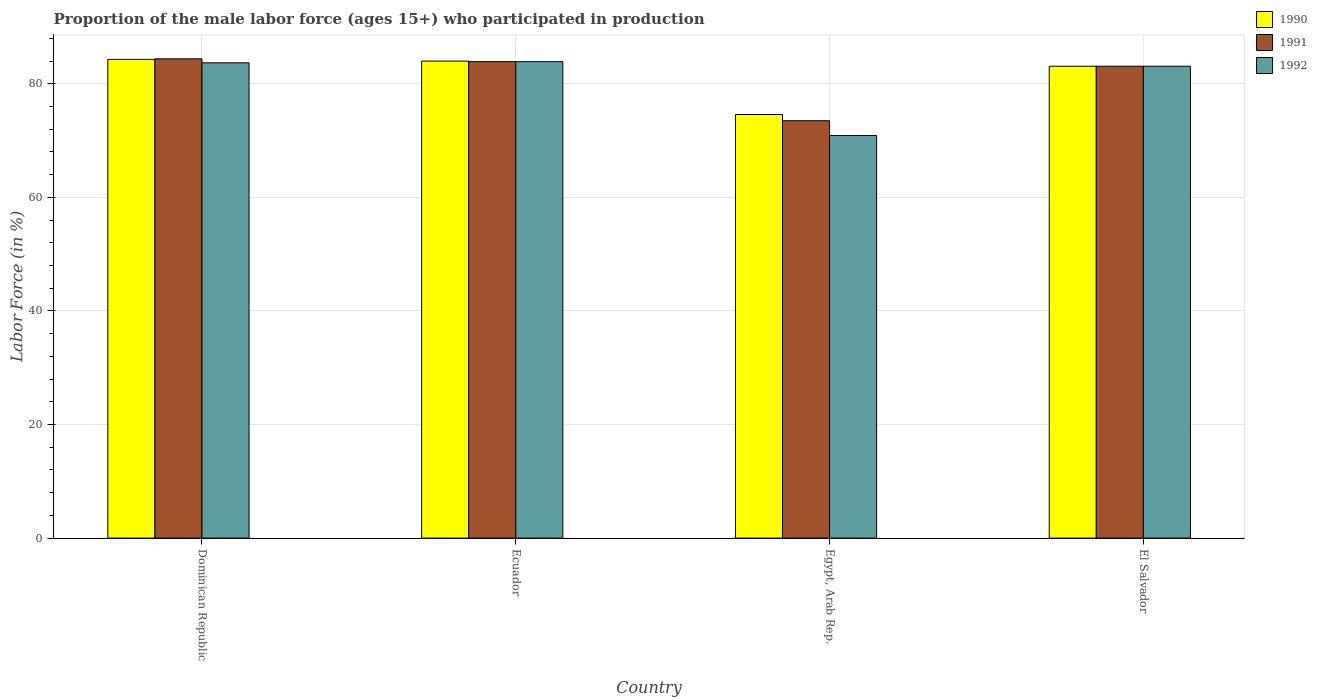Are the number of bars per tick equal to the number of legend labels?
Provide a succinct answer. Yes. How many bars are there on the 3rd tick from the right?
Ensure brevity in your answer.  3. What is the label of the 2nd group of bars from the left?
Offer a very short reply. Ecuador. In how many cases, is the number of bars for a given country not equal to the number of legend labels?
Provide a short and direct response. 0. What is the proportion of the male labor force who participated in production in 1991 in Ecuador?
Your answer should be very brief. 83.9. Across all countries, what is the maximum proportion of the male labor force who participated in production in 1991?
Offer a terse response. 84.4. Across all countries, what is the minimum proportion of the male labor force who participated in production in 1992?
Keep it short and to the point. 70.9. In which country was the proportion of the male labor force who participated in production in 1990 maximum?
Give a very brief answer. Dominican Republic. In which country was the proportion of the male labor force who participated in production in 1991 minimum?
Provide a succinct answer. Egypt, Arab Rep. What is the total proportion of the male labor force who participated in production in 1991 in the graph?
Give a very brief answer. 324.9. What is the difference between the proportion of the male labor force who participated in production in 1991 in Ecuador and that in El Salvador?
Your response must be concise. 0.8. What is the difference between the proportion of the male labor force who participated in production in 1990 in El Salvador and the proportion of the male labor force who participated in production in 1992 in Dominican Republic?
Ensure brevity in your answer.  -0.6. What is the average proportion of the male labor force who participated in production in 1992 per country?
Ensure brevity in your answer.  80.4. What is the difference between the proportion of the male labor force who participated in production of/in 1990 and proportion of the male labor force who participated in production of/in 1991 in Egypt, Arab Rep.?
Provide a succinct answer. 1.1. What is the ratio of the proportion of the male labor force who participated in production in 1992 in Dominican Republic to that in Ecuador?
Your answer should be compact. 1. Is the proportion of the male labor force who participated in production in 1990 in Dominican Republic less than that in Egypt, Arab Rep.?
Make the answer very short. No. Is the difference between the proportion of the male labor force who participated in production in 1990 in Dominican Republic and El Salvador greater than the difference between the proportion of the male labor force who participated in production in 1991 in Dominican Republic and El Salvador?
Your answer should be compact. No. What is the difference between the highest and the second highest proportion of the male labor force who participated in production in 1992?
Your answer should be very brief. -0.6. What is the difference between the highest and the lowest proportion of the male labor force who participated in production in 1991?
Your answer should be compact. 10.9. In how many countries, is the proportion of the male labor force who participated in production in 1992 greater than the average proportion of the male labor force who participated in production in 1992 taken over all countries?
Your response must be concise. 3. What does the 2nd bar from the right in El Salvador represents?
Your answer should be very brief. 1991. Is it the case that in every country, the sum of the proportion of the male labor force who participated in production in 1991 and proportion of the male labor force who participated in production in 1990 is greater than the proportion of the male labor force who participated in production in 1992?
Provide a succinct answer. Yes. Are the values on the major ticks of Y-axis written in scientific E-notation?
Keep it short and to the point. No. What is the title of the graph?
Your response must be concise. Proportion of the male labor force (ages 15+) who participated in production. Does "1981" appear as one of the legend labels in the graph?
Your answer should be very brief. No. What is the label or title of the Y-axis?
Provide a short and direct response. Labor Force (in %). What is the Labor Force (in %) in 1990 in Dominican Republic?
Make the answer very short. 84.3. What is the Labor Force (in %) of 1991 in Dominican Republic?
Keep it short and to the point. 84.4. What is the Labor Force (in %) in 1992 in Dominican Republic?
Make the answer very short. 83.7. What is the Labor Force (in %) in 1990 in Ecuador?
Offer a very short reply. 84. What is the Labor Force (in %) of 1991 in Ecuador?
Give a very brief answer. 83.9. What is the Labor Force (in %) in 1992 in Ecuador?
Provide a succinct answer. 83.9. What is the Labor Force (in %) of 1990 in Egypt, Arab Rep.?
Keep it short and to the point. 74.6. What is the Labor Force (in %) in 1991 in Egypt, Arab Rep.?
Your answer should be very brief. 73.5. What is the Labor Force (in %) in 1992 in Egypt, Arab Rep.?
Your answer should be compact. 70.9. What is the Labor Force (in %) in 1990 in El Salvador?
Make the answer very short. 83.1. What is the Labor Force (in %) of 1991 in El Salvador?
Your answer should be very brief. 83.1. What is the Labor Force (in %) of 1992 in El Salvador?
Offer a very short reply. 83.1. Across all countries, what is the maximum Labor Force (in %) of 1990?
Make the answer very short. 84.3. Across all countries, what is the maximum Labor Force (in %) in 1991?
Offer a very short reply. 84.4. Across all countries, what is the maximum Labor Force (in %) in 1992?
Keep it short and to the point. 83.9. Across all countries, what is the minimum Labor Force (in %) in 1990?
Make the answer very short. 74.6. Across all countries, what is the minimum Labor Force (in %) in 1991?
Your answer should be compact. 73.5. Across all countries, what is the minimum Labor Force (in %) in 1992?
Keep it short and to the point. 70.9. What is the total Labor Force (in %) in 1990 in the graph?
Your answer should be very brief. 326. What is the total Labor Force (in %) in 1991 in the graph?
Your response must be concise. 324.9. What is the total Labor Force (in %) of 1992 in the graph?
Provide a succinct answer. 321.6. What is the difference between the Labor Force (in %) in 1992 in Dominican Republic and that in Ecuador?
Offer a very short reply. -0.2. What is the difference between the Labor Force (in %) of 1990 in Dominican Republic and that in Egypt, Arab Rep.?
Ensure brevity in your answer.  9.7. What is the difference between the Labor Force (in %) of 1991 in Dominican Republic and that in Egypt, Arab Rep.?
Provide a succinct answer. 10.9. What is the difference between the Labor Force (in %) in 1992 in Dominican Republic and that in Egypt, Arab Rep.?
Ensure brevity in your answer.  12.8. What is the difference between the Labor Force (in %) in 1990 in Dominican Republic and that in El Salvador?
Your response must be concise. 1.2. What is the difference between the Labor Force (in %) in 1991 in Ecuador and that in Egypt, Arab Rep.?
Offer a very short reply. 10.4. What is the difference between the Labor Force (in %) of 1992 in Ecuador and that in Egypt, Arab Rep.?
Offer a terse response. 13. What is the difference between the Labor Force (in %) in 1990 in Ecuador and that in El Salvador?
Make the answer very short. 0.9. What is the difference between the Labor Force (in %) of 1991 in Ecuador and that in El Salvador?
Keep it short and to the point. 0.8. What is the difference between the Labor Force (in %) of 1992 in Ecuador and that in El Salvador?
Provide a short and direct response. 0.8. What is the difference between the Labor Force (in %) in 1992 in Egypt, Arab Rep. and that in El Salvador?
Provide a short and direct response. -12.2. What is the difference between the Labor Force (in %) of 1990 in Dominican Republic and the Labor Force (in %) of 1991 in Ecuador?
Ensure brevity in your answer.  0.4. What is the difference between the Labor Force (in %) of 1990 in Dominican Republic and the Labor Force (in %) of 1992 in Ecuador?
Offer a terse response. 0.4. What is the difference between the Labor Force (in %) of 1991 in Dominican Republic and the Labor Force (in %) of 1992 in Ecuador?
Keep it short and to the point. 0.5. What is the difference between the Labor Force (in %) in 1991 in Dominican Republic and the Labor Force (in %) in 1992 in Egypt, Arab Rep.?
Provide a short and direct response. 13.5. What is the difference between the Labor Force (in %) in 1990 in Ecuador and the Labor Force (in %) in 1991 in Egypt, Arab Rep.?
Offer a very short reply. 10.5. What is the difference between the Labor Force (in %) of 1990 in Ecuador and the Labor Force (in %) of 1991 in El Salvador?
Ensure brevity in your answer.  0.9. What is the difference between the Labor Force (in %) in 1991 in Ecuador and the Labor Force (in %) in 1992 in El Salvador?
Offer a very short reply. 0.8. What is the difference between the Labor Force (in %) in 1990 in Egypt, Arab Rep. and the Labor Force (in %) in 1991 in El Salvador?
Offer a very short reply. -8.5. What is the average Labor Force (in %) in 1990 per country?
Provide a succinct answer. 81.5. What is the average Labor Force (in %) of 1991 per country?
Give a very brief answer. 81.22. What is the average Labor Force (in %) in 1992 per country?
Make the answer very short. 80.4. What is the difference between the Labor Force (in %) in 1990 and Labor Force (in %) in 1992 in Ecuador?
Keep it short and to the point. 0.1. What is the difference between the Labor Force (in %) of 1990 and Labor Force (in %) of 1991 in El Salvador?
Offer a terse response. 0. What is the difference between the Labor Force (in %) in 1991 and Labor Force (in %) in 1992 in El Salvador?
Offer a very short reply. 0. What is the ratio of the Labor Force (in %) of 1991 in Dominican Republic to that in Ecuador?
Keep it short and to the point. 1.01. What is the ratio of the Labor Force (in %) in 1992 in Dominican Republic to that in Ecuador?
Ensure brevity in your answer.  1. What is the ratio of the Labor Force (in %) of 1990 in Dominican Republic to that in Egypt, Arab Rep.?
Your answer should be compact. 1.13. What is the ratio of the Labor Force (in %) in 1991 in Dominican Republic to that in Egypt, Arab Rep.?
Your response must be concise. 1.15. What is the ratio of the Labor Force (in %) in 1992 in Dominican Republic to that in Egypt, Arab Rep.?
Offer a very short reply. 1.18. What is the ratio of the Labor Force (in %) of 1990 in Dominican Republic to that in El Salvador?
Your answer should be very brief. 1.01. What is the ratio of the Labor Force (in %) of 1991 in Dominican Republic to that in El Salvador?
Provide a short and direct response. 1.02. What is the ratio of the Labor Force (in %) of 1992 in Dominican Republic to that in El Salvador?
Provide a succinct answer. 1.01. What is the ratio of the Labor Force (in %) of 1990 in Ecuador to that in Egypt, Arab Rep.?
Keep it short and to the point. 1.13. What is the ratio of the Labor Force (in %) in 1991 in Ecuador to that in Egypt, Arab Rep.?
Provide a short and direct response. 1.14. What is the ratio of the Labor Force (in %) in 1992 in Ecuador to that in Egypt, Arab Rep.?
Your response must be concise. 1.18. What is the ratio of the Labor Force (in %) of 1990 in Ecuador to that in El Salvador?
Your response must be concise. 1.01. What is the ratio of the Labor Force (in %) in 1991 in Ecuador to that in El Salvador?
Keep it short and to the point. 1.01. What is the ratio of the Labor Force (in %) in 1992 in Ecuador to that in El Salvador?
Ensure brevity in your answer.  1.01. What is the ratio of the Labor Force (in %) in 1990 in Egypt, Arab Rep. to that in El Salvador?
Your answer should be compact. 0.9. What is the ratio of the Labor Force (in %) of 1991 in Egypt, Arab Rep. to that in El Salvador?
Make the answer very short. 0.88. What is the ratio of the Labor Force (in %) of 1992 in Egypt, Arab Rep. to that in El Salvador?
Offer a terse response. 0.85. What is the difference between the highest and the lowest Labor Force (in %) in 1991?
Make the answer very short. 10.9. What is the difference between the highest and the lowest Labor Force (in %) of 1992?
Your answer should be compact. 13. 